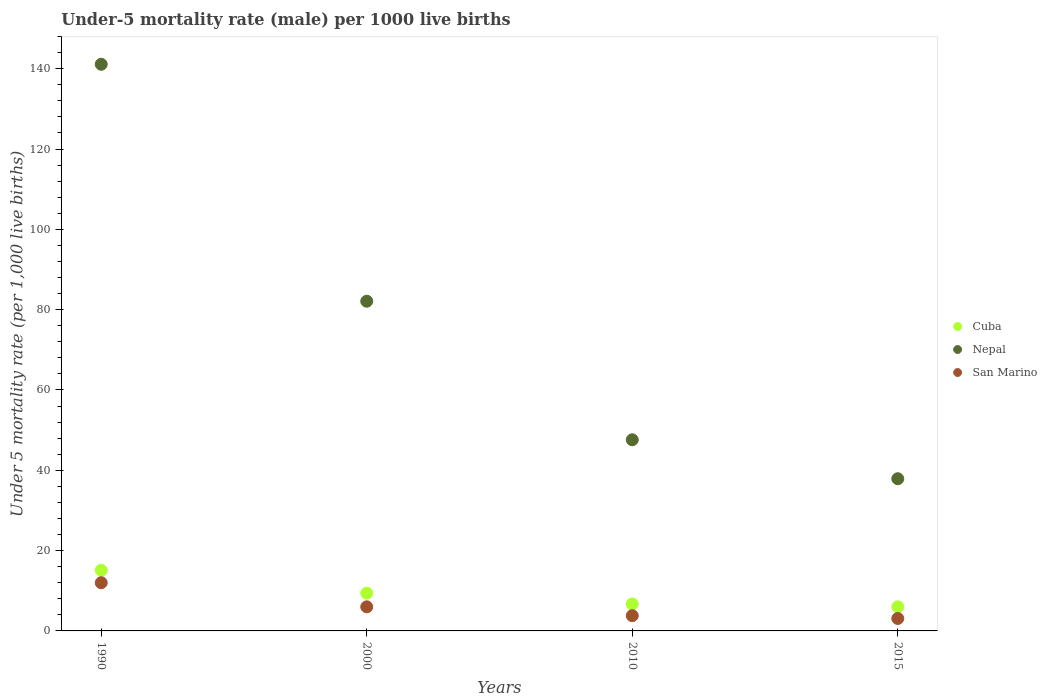Across all years, what is the maximum under-five mortality rate in Nepal?
Offer a very short reply. 141.1. In which year was the under-five mortality rate in Cuba maximum?
Make the answer very short. 1990. In which year was the under-five mortality rate in San Marino minimum?
Give a very brief answer. 2015. What is the total under-five mortality rate in San Marino in the graph?
Provide a short and direct response. 24.9. What is the difference between the under-five mortality rate in Cuba in 1990 and that in 2010?
Provide a short and direct response. 8.4. What is the difference between the under-five mortality rate in Nepal in 2000 and the under-five mortality rate in San Marino in 2010?
Ensure brevity in your answer.  78.3. What is the average under-five mortality rate in Cuba per year?
Make the answer very short. 9.3. In the year 2000, what is the difference between the under-five mortality rate in San Marino and under-five mortality rate in Cuba?
Offer a terse response. -3.4. In how many years, is the under-five mortality rate in San Marino greater than 80?
Your answer should be very brief. 0. What is the ratio of the under-five mortality rate in Cuba in 2000 to that in 2010?
Ensure brevity in your answer.  1.4. What is the difference between the highest and the second highest under-five mortality rate in San Marino?
Provide a short and direct response. 6. What is the difference between the highest and the lowest under-five mortality rate in Cuba?
Provide a succinct answer. 9.1. In how many years, is the under-five mortality rate in Nepal greater than the average under-five mortality rate in Nepal taken over all years?
Your response must be concise. 2. Is the under-five mortality rate in San Marino strictly greater than the under-five mortality rate in Nepal over the years?
Ensure brevity in your answer.  No. Is the under-five mortality rate in Cuba strictly less than the under-five mortality rate in San Marino over the years?
Your answer should be very brief. No. How many dotlines are there?
Give a very brief answer. 3. How many years are there in the graph?
Your response must be concise. 4. What is the difference between two consecutive major ticks on the Y-axis?
Provide a succinct answer. 20. Are the values on the major ticks of Y-axis written in scientific E-notation?
Provide a succinct answer. No. Does the graph contain any zero values?
Offer a very short reply. No. How many legend labels are there?
Your response must be concise. 3. How are the legend labels stacked?
Provide a short and direct response. Vertical. What is the title of the graph?
Give a very brief answer. Under-5 mortality rate (male) per 1000 live births. What is the label or title of the X-axis?
Give a very brief answer. Years. What is the label or title of the Y-axis?
Provide a short and direct response. Under 5 mortality rate (per 1,0 live births). What is the Under 5 mortality rate (per 1,000 live births) of Nepal in 1990?
Your response must be concise. 141.1. What is the Under 5 mortality rate (per 1,000 live births) in San Marino in 1990?
Your answer should be very brief. 12. What is the Under 5 mortality rate (per 1,000 live births) of Nepal in 2000?
Provide a short and direct response. 82.1. What is the Under 5 mortality rate (per 1,000 live births) of San Marino in 2000?
Provide a short and direct response. 6. What is the Under 5 mortality rate (per 1,000 live births) of Nepal in 2010?
Provide a short and direct response. 47.6. What is the Under 5 mortality rate (per 1,000 live births) of Cuba in 2015?
Keep it short and to the point. 6. What is the Under 5 mortality rate (per 1,000 live births) of Nepal in 2015?
Give a very brief answer. 37.9. Across all years, what is the maximum Under 5 mortality rate (per 1,000 live births) of Nepal?
Provide a short and direct response. 141.1. Across all years, what is the minimum Under 5 mortality rate (per 1,000 live births) of Nepal?
Offer a very short reply. 37.9. Across all years, what is the minimum Under 5 mortality rate (per 1,000 live births) in San Marino?
Offer a terse response. 3.1. What is the total Under 5 mortality rate (per 1,000 live births) in Cuba in the graph?
Give a very brief answer. 37.2. What is the total Under 5 mortality rate (per 1,000 live births) in Nepal in the graph?
Your answer should be compact. 308.7. What is the total Under 5 mortality rate (per 1,000 live births) in San Marino in the graph?
Ensure brevity in your answer.  24.9. What is the difference between the Under 5 mortality rate (per 1,000 live births) of Cuba in 1990 and that in 2000?
Offer a terse response. 5.7. What is the difference between the Under 5 mortality rate (per 1,000 live births) of Nepal in 1990 and that in 2000?
Provide a short and direct response. 59. What is the difference between the Under 5 mortality rate (per 1,000 live births) of Cuba in 1990 and that in 2010?
Make the answer very short. 8.4. What is the difference between the Under 5 mortality rate (per 1,000 live births) in Nepal in 1990 and that in 2010?
Your answer should be very brief. 93.5. What is the difference between the Under 5 mortality rate (per 1,000 live births) in Nepal in 1990 and that in 2015?
Make the answer very short. 103.2. What is the difference between the Under 5 mortality rate (per 1,000 live births) of Nepal in 2000 and that in 2010?
Make the answer very short. 34.5. What is the difference between the Under 5 mortality rate (per 1,000 live births) of San Marino in 2000 and that in 2010?
Your answer should be compact. 2.2. What is the difference between the Under 5 mortality rate (per 1,000 live births) of Cuba in 2000 and that in 2015?
Ensure brevity in your answer.  3.4. What is the difference between the Under 5 mortality rate (per 1,000 live births) in Nepal in 2000 and that in 2015?
Provide a succinct answer. 44.2. What is the difference between the Under 5 mortality rate (per 1,000 live births) of Cuba in 1990 and the Under 5 mortality rate (per 1,000 live births) of Nepal in 2000?
Offer a terse response. -67. What is the difference between the Under 5 mortality rate (per 1,000 live births) of Nepal in 1990 and the Under 5 mortality rate (per 1,000 live births) of San Marino in 2000?
Keep it short and to the point. 135.1. What is the difference between the Under 5 mortality rate (per 1,000 live births) in Cuba in 1990 and the Under 5 mortality rate (per 1,000 live births) in Nepal in 2010?
Your answer should be very brief. -32.5. What is the difference between the Under 5 mortality rate (per 1,000 live births) in Cuba in 1990 and the Under 5 mortality rate (per 1,000 live births) in San Marino in 2010?
Offer a very short reply. 11.3. What is the difference between the Under 5 mortality rate (per 1,000 live births) of Nepal in 1990 and the Under 5 mortality rate (per 1,000 live births) of San Marino in 2010?
Offer a terse response. 137.3. What is the difference between the Under 5 mortality rate (per 1,000 live births) in Cuba in 1990 and the Under 5 mortality rate (per 1,000 live births) in Nepal in 2015?
Provide a succinct answer. -22.8. What is the difference between the Under 5 mortality rate (per 1,000 live births) of Cuba in 1990 and the Under 5 mortality rate (per 1,000 live births) of San Marino in 2015?
Give a very brief answer. 12. What is the difference between the Under 5 mortality rate (per 1,000 live births) in Nepal in 1990 and the Under 5 mortality rate (per 1,000 live births) in San Marino in 2015?
Your answer should be compact. 138. What is the difference between the Under 5 mortality rate (per 1,000 live births) in Cuba in 2000 and the Under 5 mortality rate (per 1,000 live births) in Nepal in 2010?
Your response must be concise. -38.2. What is the difference between the Under 5 mortality rate (per 1,000 live births) of Cuba in 2000 and the Under 5 mortality rate (per 1,000 live births) of San Marino in 2010?
Offer a very short reply. 5.6. What is the difference between the Under 5 mortality rate (per 1,000 live births) of Nepal in 2000 and the Under 5 mortality rate (per 1,000 live births) of San Marino in 2010?
Provide a succinct answer. 78.3. What is the difference between the Under 5 mortality rate (per 1,000 live births) in Cuba in 2000 and the Under 5 mortality rate (per 1,000 live births) in Nepal in 2015?
Your answer should be compact. -28.5. What is the difference between the Under 5 mortality rate (per 1,000 live births) in Cuba in 2000 and the Under 5 mortality rate (per 1,000 live births) in San Marino in 2015?
Make the answer very short. 6.3. What is the difference between the Under 5 mortality rate (per 1,000 live births) of Nepal in 2000 and the Under 5 mortality rate (per 1,000 live births) of San Marino in 2015?
Your response must be concise. 79. What is the difference between the Under 5 mortality rate (per 1,000 live births) in Cuba in 2010 and the Under 5 mortality rate (per 1,000 live births) in Nepal in 2015?
Offer a terse response. -31.2. What is the difference between the Under 5 mortality rate (per 1,000 live births) in Cuba in 2010 and the Under 5 mortality rate (per 1,000 live births) in San Marino in 2015?
Provide a short and direct response. 3.6. What is the difference between the Under 5 mortality rate (per 1,000 live births) of Nepal in 2010 and the Under 5 mortality rate (per 1,000 live births) of San Marino in 2015?
Give a very brief answer. 44.5. What is the average Under 5 mortality rate (per 1,000 live births) of Nepal per year?
Make the answer very short. 77.17. What is the average Under 5 mortality rate (per 1,000 live births) of San Marino per year?
Keep it short and to the point. 6.22. In the year 1990, what is the difference between the Under 5 mortality rate (per 1,000 live births) of Cuba and Under 5 mortality rate (per 1,000 live births) of Nepal?
Offer a very short reply. -126. In the year 1990, what is the difference between the Under 5 mortality rate (per 1,000 live births) in Nepal and Under 5 mortality rate (per 1,000 live births) in San Marino?
Your answer should be compact. 129.1. In the year 2000, what is the difference between the Under 5 mortality rate (per 1,000 live births) in Cuba and Under 5 mortality rate (per 1,000 live births) in Nepal?
Offer a terse response. -72.7. In the year 2000, what is the difference between the Under 5 mortality rate (per 1,000 live births) of Cuba and Under 5 mortality rate (per 1,000 live births) of San Marino?
Make the answer very short. 3.4. In the year 2000, what is the difference between the Under 5 mortality rate (per 1,000 live births) of Nepal and Under 5 mortality rate (per 1,000 live births) of San Marino?
Ensure brevity in your answer.  76.1. In the year 2010, what is the difference between the Under 5 mortality rate (per 1,000 live births) of Cuba and Under 5 mortality rate (per 1,000 live births) of Nepal?
Your answer should be compact. -40.9. In the year 2010, what is the difference between the Under 5 mortality rate (per 1,000 live births) of Cuba and Under 5 mortality rate (per 1,000 live births) of San Marino?
Your response must be concise. 2.9. In the year 2010, what is the difference between the Under 5 mortality rate (per 1,000 live births) in Nepal and Under 5 mortality rate (per 1,000 live births) in San Marino?
Your answer should be very brief. 43.8. In the year 2015, what is the difference between the Under 5 mortality rate (per 1,000 live births) in Cuba and Under 5 mortality rate (per 1,000 live births) in Nepal?
Provide a succinct answer. -31.9. In the year 2015, what is the difference between the Under 5 mortality rate (per 1,000 live births) of Cuba and Under 5 mortality rate (per 1,000 live births) of San Marino?
Your answer should be very brief. 2.9. In the year 2015, what is the difference between the Under 5 mortality rate (per 1,000 live births) of Nepal and Under 5 mortality rate (per 1,000 live births) of San Marino?
Your response must be concise. 34.8. What is the ratio of the Under 5 mortality rate (per 1,000 live births) in Cuba in 1990 to that in 2000?
Ensure brevity in your answer.  1.61. What is the ratio of the Under 5 mortality rate (per 1,000 live births) in Nepal in 1990 to that in 2000?
Offer a terse response. 1.72. What is the ratio of the Under 5 mortality rate (per 1,000 live births) of Cuba in 1990 to that in 2010?
Your answer should be compact. 2.25. What is the ratio of the Under 5 mortality rate (per 1,000 live births) in Nepal in 1990 to that in 2010?
Give a very brief answer. 2.96. What is the ratio of the Under 5 mortality rate (per 1,000 live births) in San Marino in 1990 to that in 2010?
Offer a terse response. 3.16. What is the ratio of the Under 5 mortality rate (per 1,000 live births) in Cuba in 1990 to that in 2015?
Provide a succinct answer. 2.52. What is the ratio of the Under 5 mortality rate (per 1,000 live births) of Nepal in 1990 to that in 2015?
Give a very brief answer. 3.72. What is the ratio of the Under 5 mortality rate (per 1,000 live births) in San Marino in 1990 to that in 2015?
Keep it short and to the point. 3.87. What is the ratio of the Under 5 mortality rate (per 1,000 live births) in Cuba in 2000 to that in 2010?
Ensure brevity in your answer.  1.4. What is the ratio of the Under 5 mortality rate (per 1,000 live births) of Nepal in 2000 to that in 2010?
Provide a succinct answer. 1.72. What is the ratio of the Under 5 mortality rate (per 1,000 live births) of San Marino in 2000 to that in 2010?
Provide a short and direct response. 1.58. What is the ratio of the Under 5 mortality rate (per 1,000 live births) in Cuba in 2000 to that in 2015?
Keep it short and to the point. 1.57. What is the ratio of the Under 5 mortality rate (per 1,000 live births) of Nepal in 2000 to that in 2015?
Offer a very short reply. 2.17. What is the ratio of the Under 5 mortality rate (per 1,000 live births) of San Marino in 2000 to that in 2015?
Your answer should be very brief. 1.94. What is the ratio of the Under 5 mortality rate (per 1,000 live births) in Cuba in 2010 to that in 2015?
Ensure brevity in your answer.  1.12. What is the ratio of the Under 5 mortality rate (per 1,000 live births) in Nepal in 2010 to that in 2015?
Your response must be concise. 1.26. What is the ratio of the Under 5 mortality rate (per 1,000 live births) of San Marino in 2010 to that in 2015?
Ensure brevity in your answer.  1.23. What is the difference between the highest and the second highest Under 5 mortality rate (per 1,000 live births) of Nepal?
Offer a very short reply. 59. What is the difference between the highest and the second highest Under 5 mortality rate (per 1,000 live births) in San Marino?
Give a very brief answer. 6. What is the difference between the highest and the lowest Under 5 mortality rate (per 1,000 live births) of Cuba?
Give a very brief answer. 9.1. What is the difference between the highest and the lowest Under 5 mortality rate (per 1,000 live births) in Nepal?
Offer a very short reply. 103.2. What is the difference between the highest and the lowest Under 5 mortality rate (per 1,000 live births) of San Marino?
Make the answer very short. 8.9. 